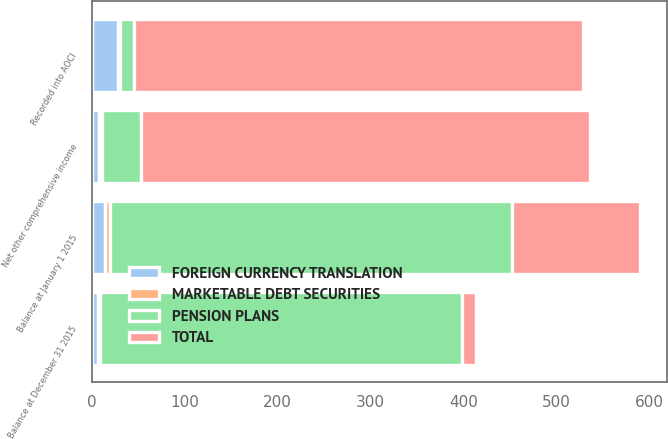Convert chart. <chart><loc_0><loc_0><loc_500><loc_500><stacked_bar_chart><ecel><fcel>Balance at January 1 2015<fcel>Recorded into AOCI<fcel>Net other comprehensive income<fcel>Balance at December 31 2015<nl><fcel>FOREIGN CURRENCY TRANSLATION<fcel>13.5<fcel>27.9<fcel>7.1<fcel>6.4<nl><fcel>MARKETABLE DEBT SECURITIES<fcel>5.3<fcel>1.7<fcel>3.2<fcel>2.1<nl><fcel>PENSION PLANS<fcel>433.1<fcel>15.1<fcel>42.7<fcel>390.4<nl><fcel>TOTAL<fcel>138.5<fcel>483.8<fcel>483.8<fcel>15.1<nl></chart> 